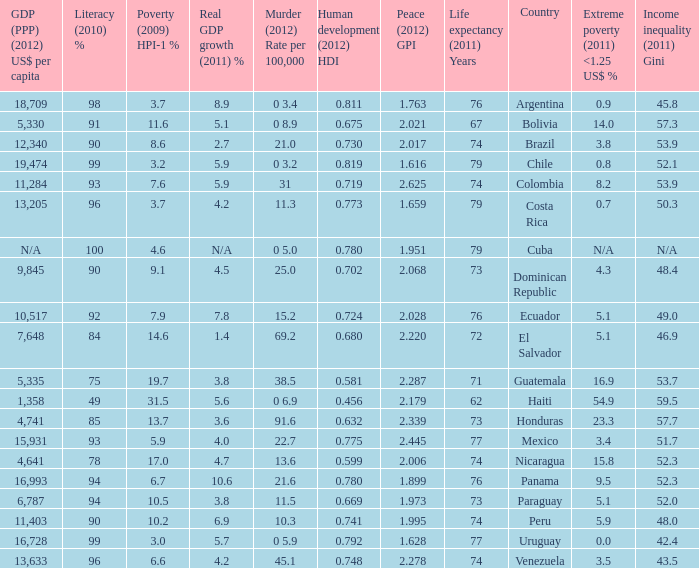What murder (2012) rate per 100,00 also has a 1.616 as the peace (2012) GPI? 0 3.2. 